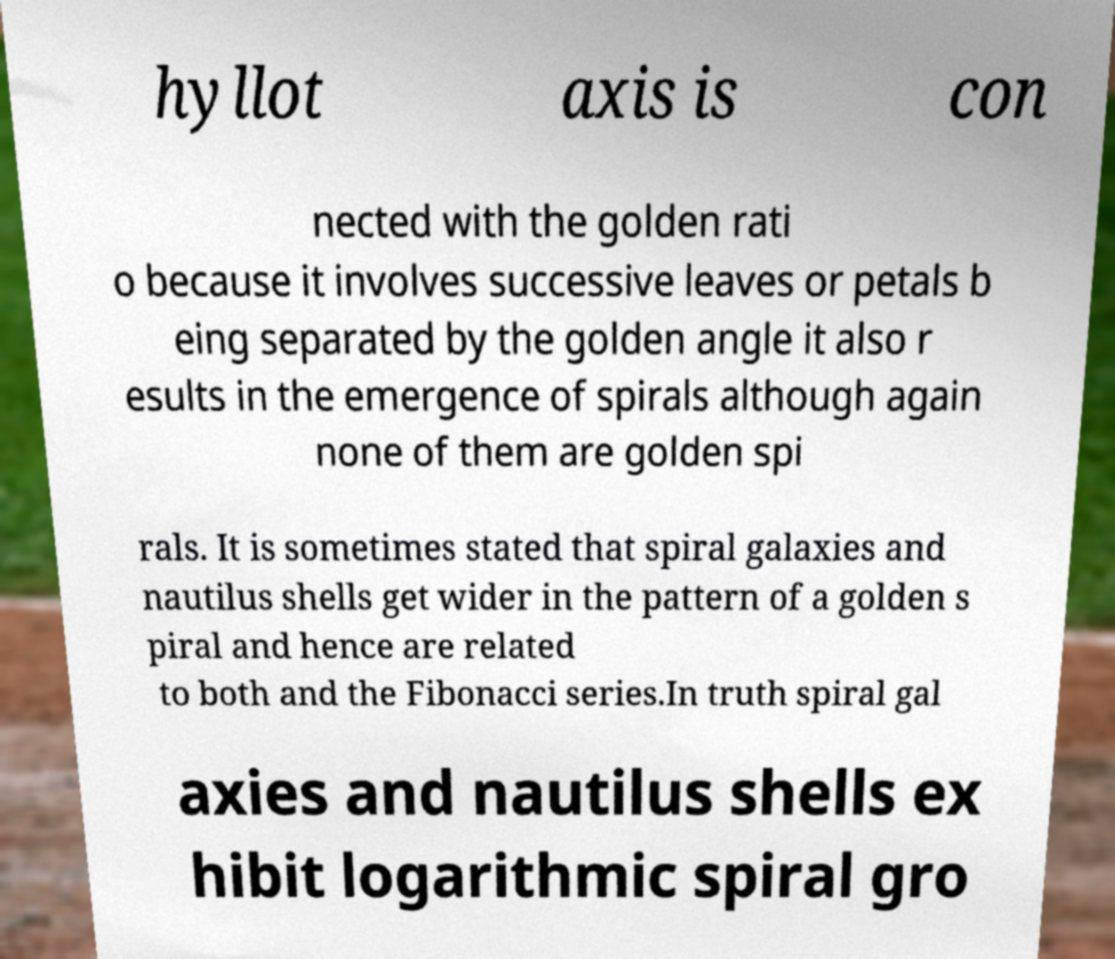Could you assist in decoding the text presented in this image and type it out clearly? hyllot axis is con nected with the golden rati o because it involves successive leaves or petals b eing separated by the golden angle it also r esults in the emergence of spirals although again none of them are golden spi rals. It is sometimes stated that spiral galaxies and nautilus shells get wider in the pattern of a golden s piral and hence are related to both and the Fibonacci series.In truth spiral gal axies and nautilus shells ex hibit logarithmic spiral gro 